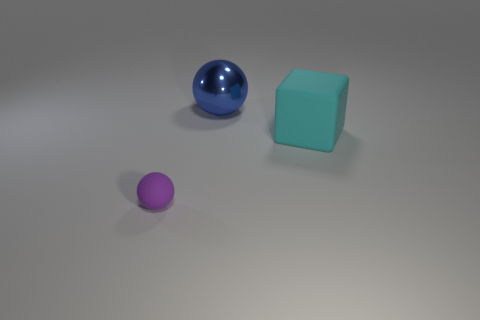What number of other objects are the same shape as the big cyan thing?
Your answer should be very brief. 0. There is a ball on the right side of the purple object; what is it made of?
Ensure brevity in your answer.  Metal. Are there an equal number of big cyan blocks behind the large blue metallic object and large blue rubber cylinders?
Your answer should be very brief. Yes. Do the large cyan rubber thing and the blue thing have the same shape?
Your answer should be compact. No. Is there any other thing of the same color as the big rubber thing?
Your response must be concise. No. What shape is the object that is both right of the small matte thing and in front of the large blue sphere?
Make the answer very short. Cube. Is the number of big metal things in front of the tiny object the same as the number of blue objects that are behind the large blue shiny ball?
Your answer should be very brief. Yes. What number of cylinders are metallic things or large cyan objects?
Keep it short and to the point. 0. How many large objects have the same material as the large cyan cube?
Keep it short and to the point. 0. What is the material of the thing that is both on the left side of the big matte thing and in front of the big blue metal thing?
Make the answer very short. Rubber. 